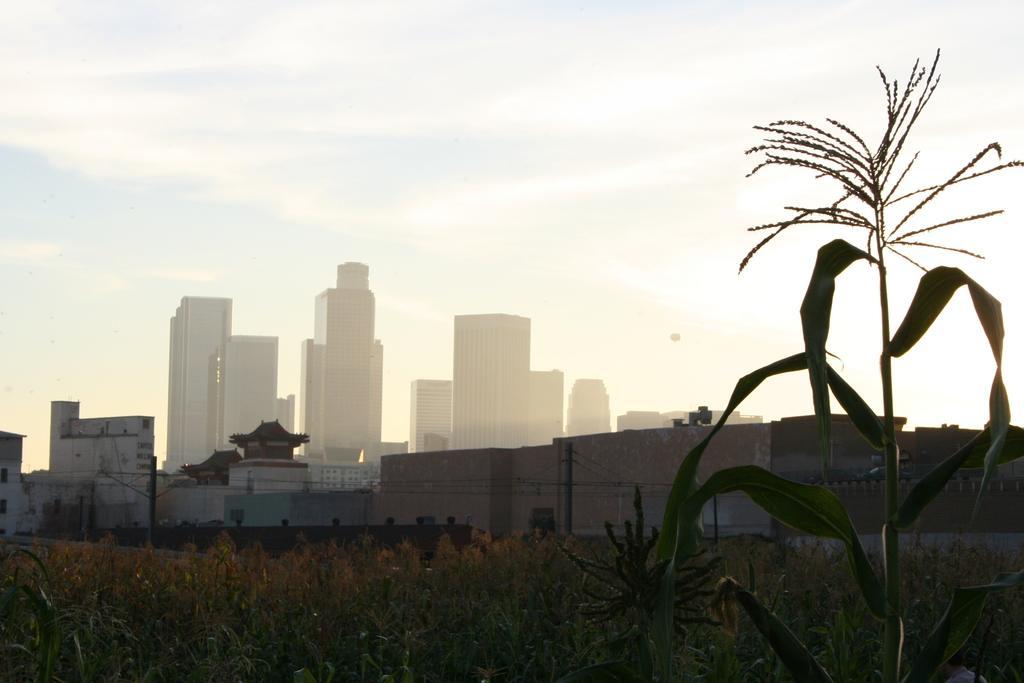Please provide a concise description of this image. At the bottom of the image there are some plants. In the middle of the image there are some buildings. At the top of the image there are some clouds in the sky. 